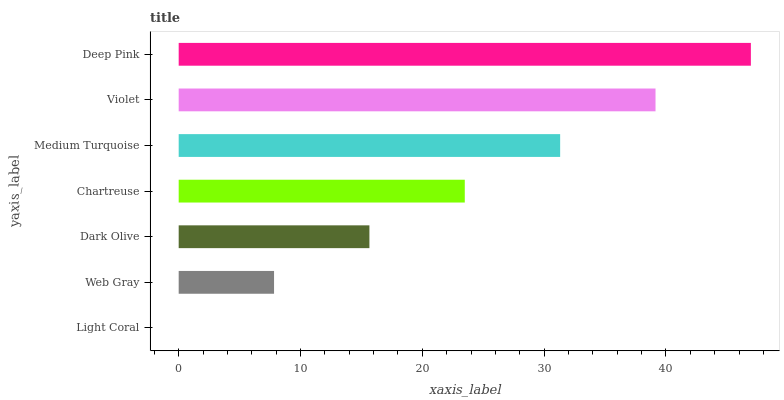Is Light Coral the minimum?
Answer yes or no. Yes. Is Deep Pink the maximum?
Answer yes or no. Yes. Is Web Gray the minimum?
Answer yes or no. No. Is Web Gray the maximum?
Answer yes or no. No. Is Web Gray greater than Light Coral?
Answer yes or no. Yes. Is Light Coral less than Web Gray?
Answer yes or no. Yes. Is Light Coral greater than Web Gray?
Answer yes or no. No. Is Web Gray less than Light Coral?
Answer yes or no. No. Is Chartreuse the high median?
Answer yes or no. Yes. Is Chartreuse the low median?
Answer yes or no. Yes. Is Violet the high median?
Answer yes or no. No. Is Web Gray the low median?
Answer yes or no. No. 